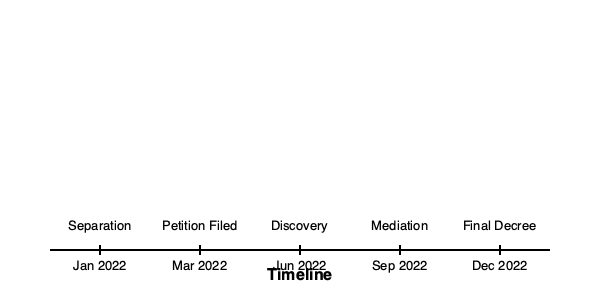Based on the timeline provided, what is the duration between the filing of the divorce petition and the completion of the discovery process? To determine the duration between the filing of the divorce petition and the completion of the discovery process, we need to follow these steps:

1. Identify the date when the petition was filed:
   - The petition was filed in March 2022

2. Identify the date when the discovery process was completed:
   - The discovery process was completed in June 2022

3. Calculate the time difference between these two dates:
   - March to April: 1 month
   - April to May: 1 month
   - May to June: 1 month
   
4. Sum up the total duration:
   - Total duration = 1 + 1 + 1 = 3 months

Therefore, the duration between the filing of the divorce petition and the completion of the discovery process is 3 months.
Answer: 3 months 